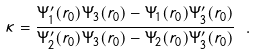<formula> <loc_0><loc_0><loc_500><loc_500>\kappa = \frac { \Psi ^ { \prime } _ { 1 } ( r _ { 0 } ) \Psi _ { 3 } ( r _ { 0 } ) - \Psi _ { 1 } ( r _ { 0 } ) \Psi ^ { \prime } _ { 3 } ( r _ { 0 } ) } { \Psi ^ { \prime } _ { 2 } ( r _ { 0 } ) \Psi _ { 3 } ( r _ { 0 } ) - \Psi _ { 2 } ( r _ { 0 } ) \Psi ^ { \prime } _ { 3 } ( r _ { 0 } ) } \ .</formula> 